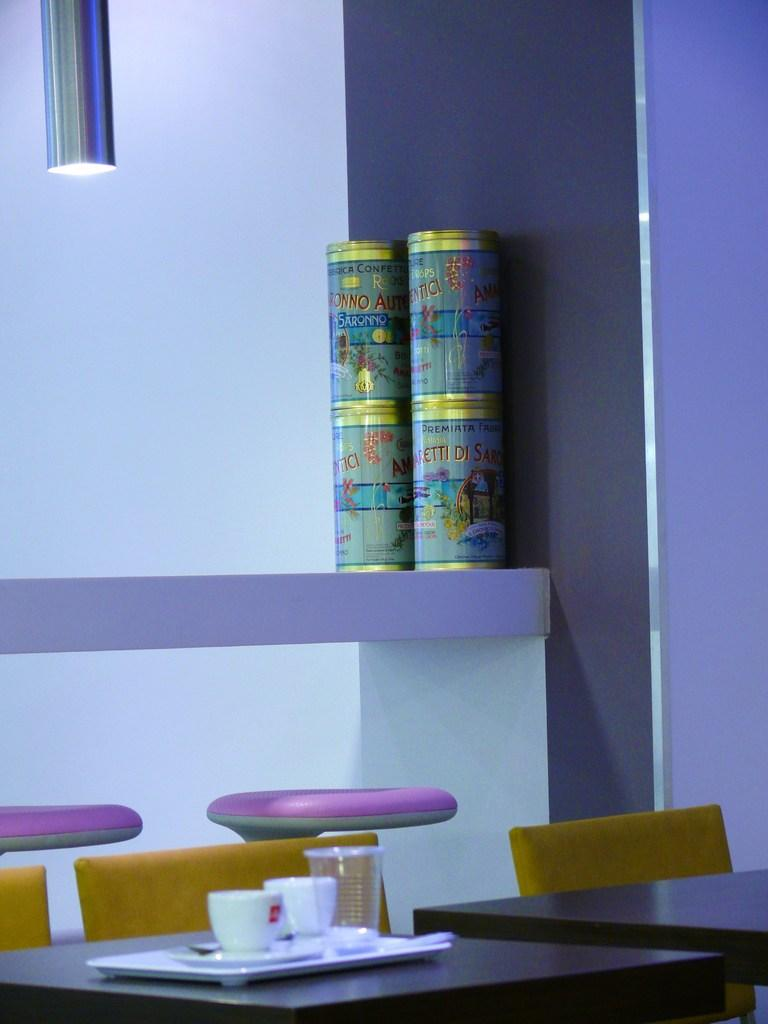What type of furniture is present in the image? There is a rack, tables, and chairs in the image. What type of lighting is visible in the image? There is a light in the image. What type of wall is present in the image? There is a wall in the image. What type of dishware is visible in the image? There are cups in the image. What other objects can be seen in the image? There are other objects in the image. Can you tell me how many times the kitten cracks a fact in the image? There is no kitten or fact present in the image, so this question cannot be answered. 